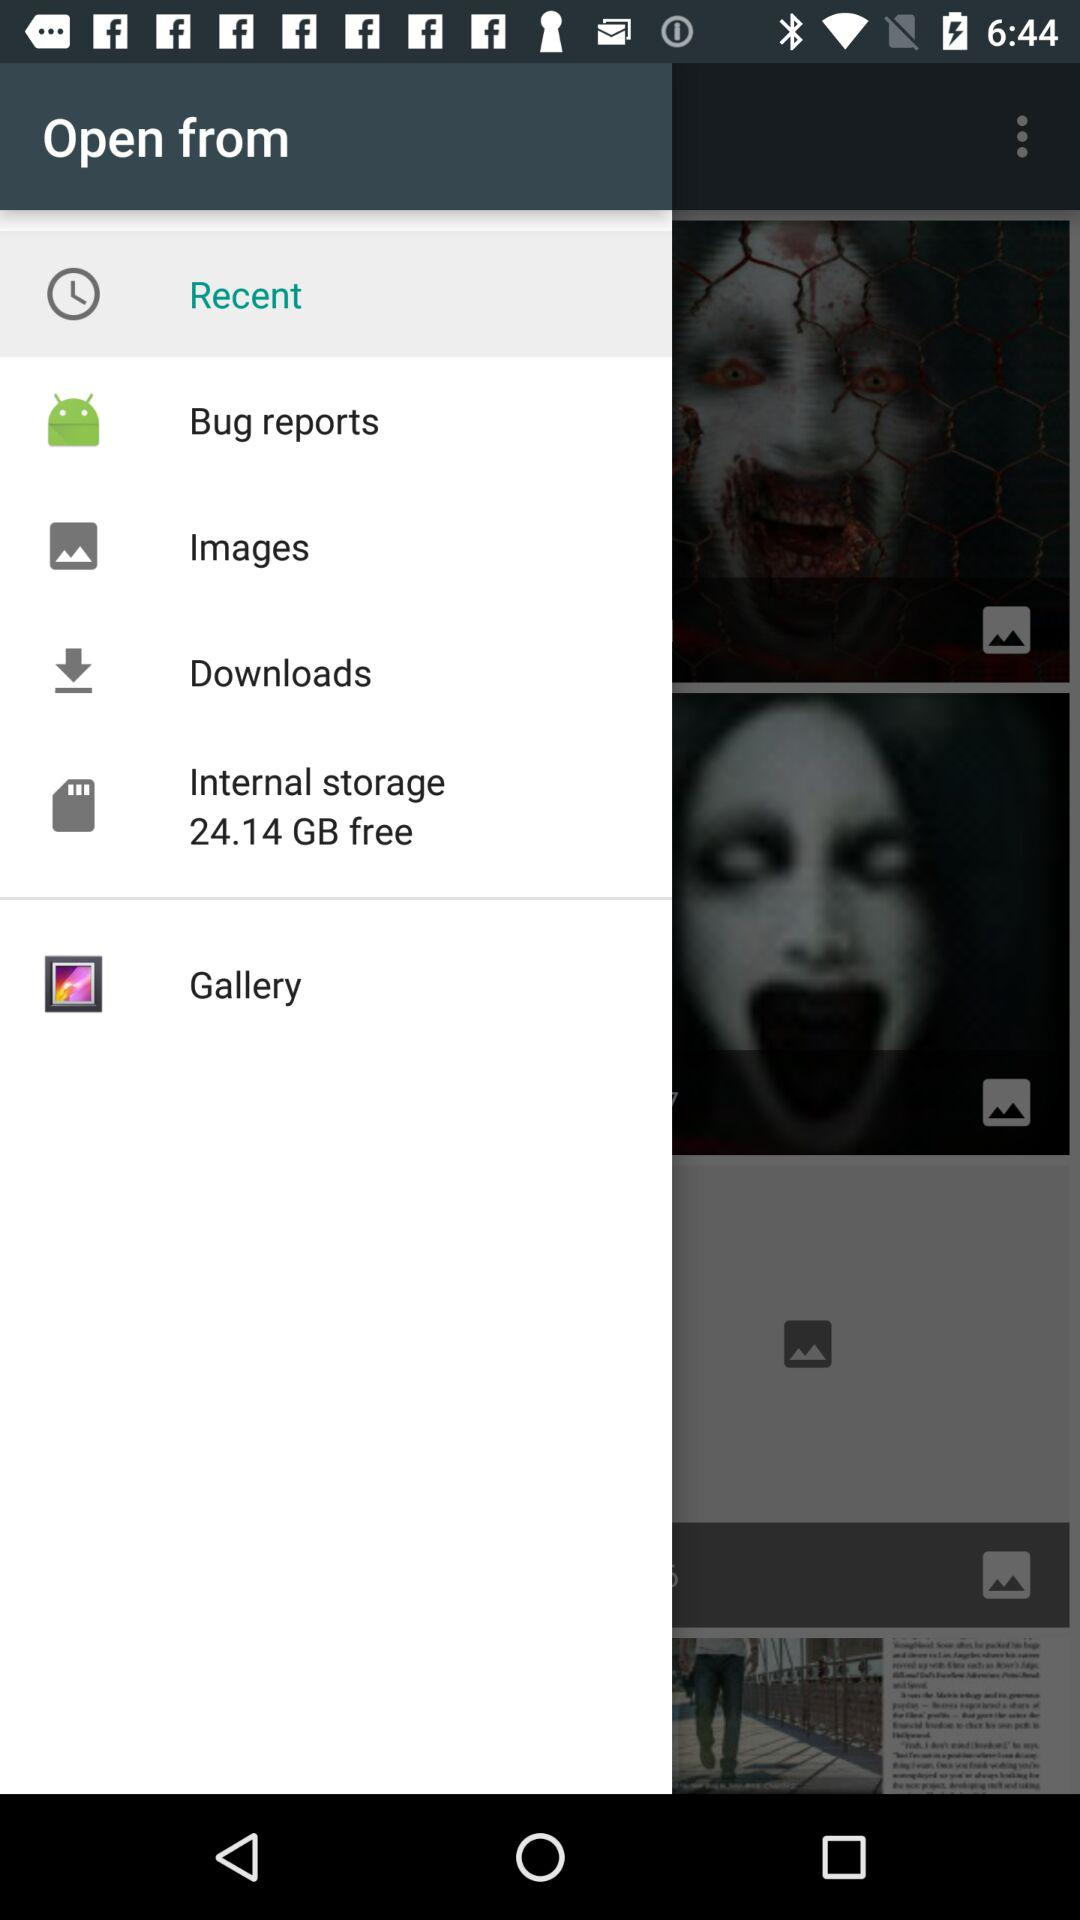How much internal storage is free? There is 24.14 GB of free internal storage. 